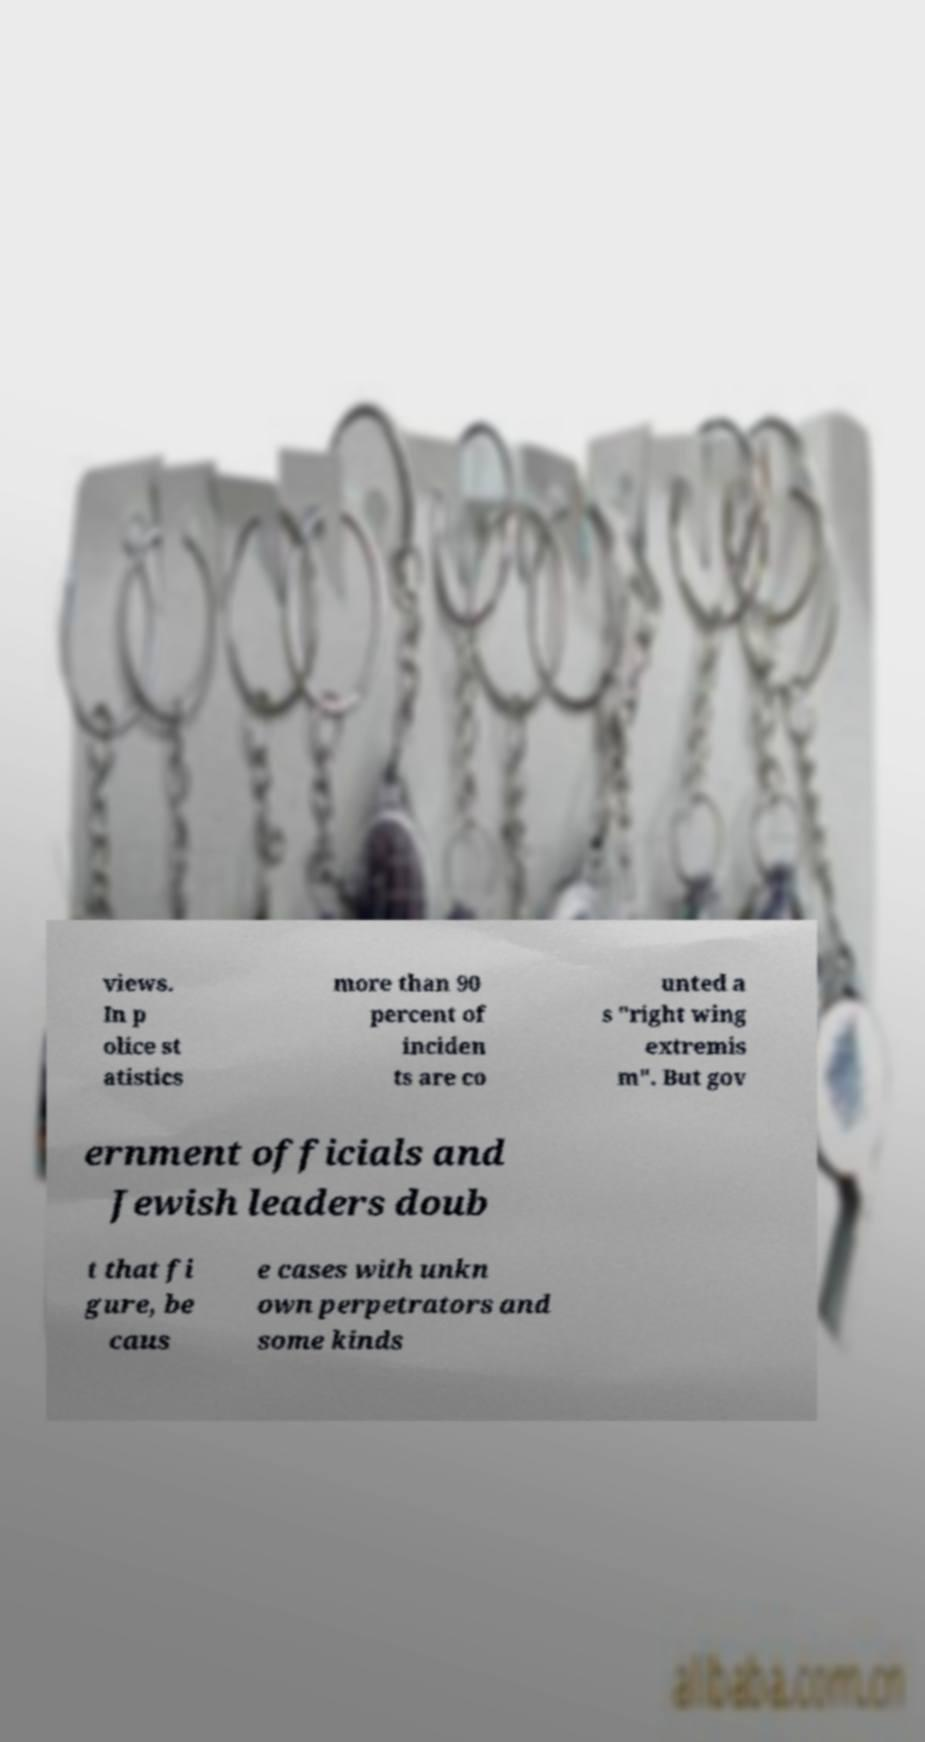For documentation purposes, I need the text within this image transcribed. Could you provide that? views. In p olice st atistics more than 90 percent of inciden ts are co unted a s "right wing extremis m". But gov ernment officials and Jewish leaders doub t that fi gure, be caus e cases with unkn own perpetrators and some kinds 